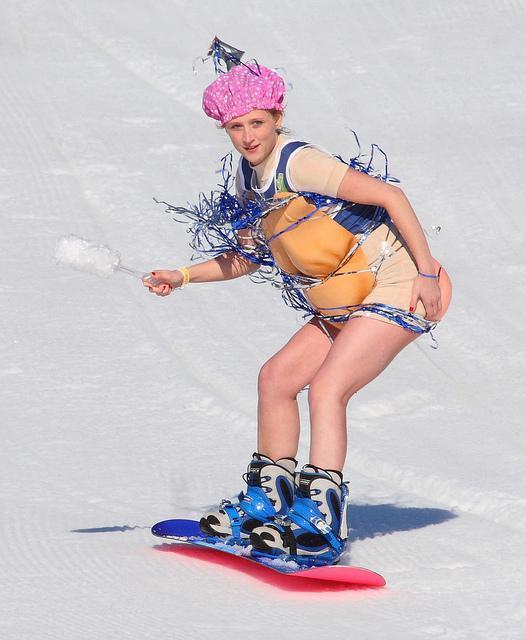How many snowboards can you see?
Give a very brief answer. 1. How many ski poles is the person holding?
Give a very brief answer. 0. 